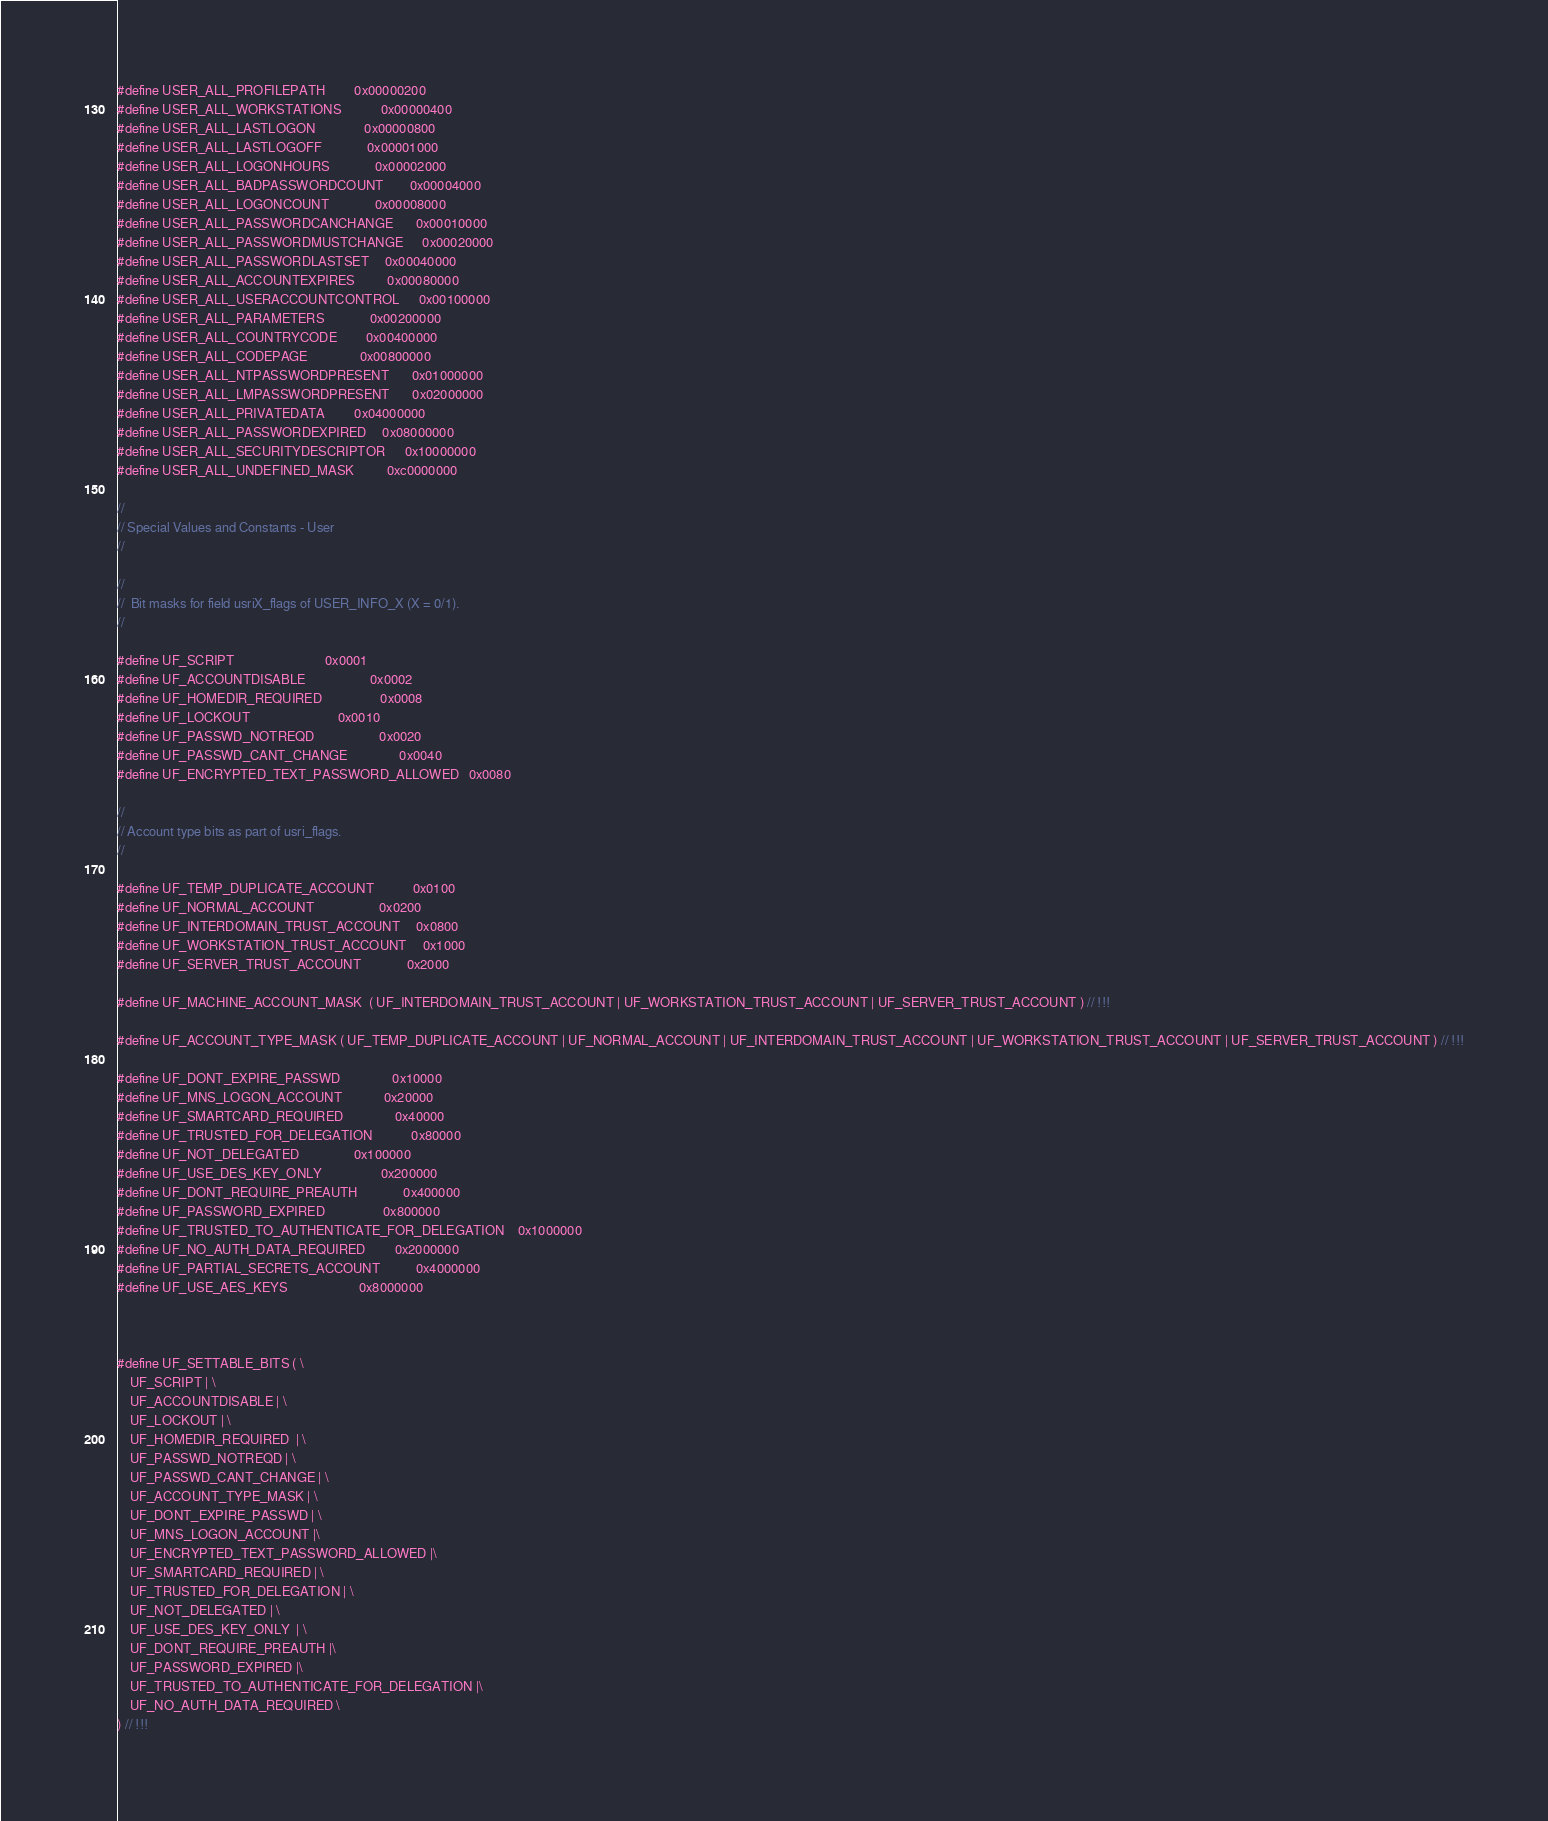<code> <loc_0><loc_0><loc_500><loc_500><_C_>#define USER_ALL_PROFILEPATH			0x00000200
#define USER_ALL_WORKSTATIONS			0x00000400
#define USER_ALL_LASTLOGON				0x00000800
#define USER_ALL_LASTLOGOFF				0x00001000
#define USER_ALL_LOGONHOURS				0x00002000
#define USER_ALL_BADPASSWORDCOUNT		0x00004000
#define USER_ALL_LOGONCOUNT				0x00008000
#define USER_ALL_PASSWORDCANCHANGE		0x00010000
#define USER_ALL_PASSWORDMUSTCHANGE		0x00020000
#define USER_ALL_PASSWORDLASTSET		0x00040000
#define USER_ALL_ACCOUNTEXPIRES			0x00080000
#define USER_ALL_USERACCOUNTCONTROL		0x00100000
#define USER_ALL_PARAMETERS				0x00200000
#define USER_ALL_COUNTRYCODE			0x00400000
#define USER_ALL_CODEPAGE				0x00800000
#define USER_ALL_NTPASSWORDPRESENT		0x01000000
#define USER_ALL_LMPASSWORDPRESENT		0x02000000
#define USER_ALL_PRIVATEDATA			0x04000000
#define USER_ALL_PASSWORDEXPIRED		0x08000000
#define USER_ALL_SECURITYDESCRIPTOR		0x10000000
#define USER_ALL_UNDEFINED_MASK			0xc0000000

//
// Special Values and Constants - User
//

//
//  Bit masks for field usriX_flags of USER_INFO_X (X = 0/1).
//

#define UF_SCRIPT							0x0001
#define UF_ACCOUNTDISABLE					0x0002
#define UF_HOMEDIR_REQUIRED					0x0008
#define UF_LOCKOUT							0x0010
#define UF_PASSWD_NOTREQD					0x0020
#define UF_PASSWD_CANT_CHANGE				0x0040
#define UF_ENCRYPTED_TEXT_PASSWORD_ALLOWED	0x0080

//
// Account type bits as part of usri_flags.
//

#define UF_TEMP_DUPLICATE_ACCOUNT			0x0100
#define UF_NORMAL_ACCOUNT					0x0200
#define UF_INTERDOMAIN_TRUST_ACCOUNT		0x0800
#define UF_WORKSTATION_TRUST_ACCOUNT		0x1000
#define UF_SERVER_TRUST_ACCOUNT				0x2000

#define UF_MACHINE_ACCOUNT_MASK	( UF_INTERDOMAIN_TRUST_ACCOUNT | UF_WORKSTATION_TRUST_ACCOUNT | UF_SERVER_TRUST_ACCOUNT ) // !!!

#define UF_ACCOUNT_TYPE_MASK	( UF_TEMP_DUPLICATE_ACCOUNT | UF_NORMAL_ACCOUNT | UF_INTERDOMAIN_TRUST_ACCOUNT | UF_WORKSTATION_TRUST_ACCOUNT | UF_SERVER_TRUST_ACCOUNT ) // !!!

#define UF_DONT_EXPIRE_PASSWD				0x10000
#define UF_MNS_LOGON_ACCOUNT				0x20000
#define UF_SMARTCARD_REQUIRED				0x40000
#define UF_TRUSTED_FOR_DELEGATION			0x80000
#define UF_NOT_DELEGATED					0x100000
#define UF_USE_DES_KEY_ONLY					0x200000
#define UF_DONT_REQUIRE_PREAUTH				0x400000
#define UF_PASSWORD_EXPIRED					0x800000
#define UF_TRUSTED_TO_AUTHENTICATE_FOR_DELEGATION	0x1000000
#define UF_NO_AUTH_DATA_REQUIRED			0x2000000
#define UF_PARTIAL_SECRETS_ACCOUNT			0x4000000
#define UF_USE_AES_KEYS						0x8000000



#define UF_SETTABLE_BITS	( \
	UF_SCRIPT | \
	UF_ACCOUNTDISABLE | \
	UF_LOCKOUT | \
	UF_HOMEDIR_REQUIRED  | \
	UF_PASSWD_NOTREQD | \
	UF_PASSWD_CANT_CHANGE | \
	UF_ACCOUNT_TYPE_MASK | \
	UF_DONT_EXPIRE_PASSWD | \
	UF_MNS_LOGON_ACCOUNT |\
	UF_ENCRYPTED_TEXT_PASSWORD_ALLOWED |\
	UF_SMARTCARD_REQUIRED | \
	UF_TRUSTED_FOR_DELEGATION | \
	UF_NOT_DELEGATED | \
	UF_USE_DES_KEY_ONLY  | \
	UF_DONT_REQUIRE_PREAUTH |\
	UF_PASSWORD_EXPIRED |\
	UF_TRUSTED_TO_AUTHENTICATE_FOR_DELEGATION |\
	UF_NO_AUTH_DATA_REQUIRED \
) // !!!</code> 